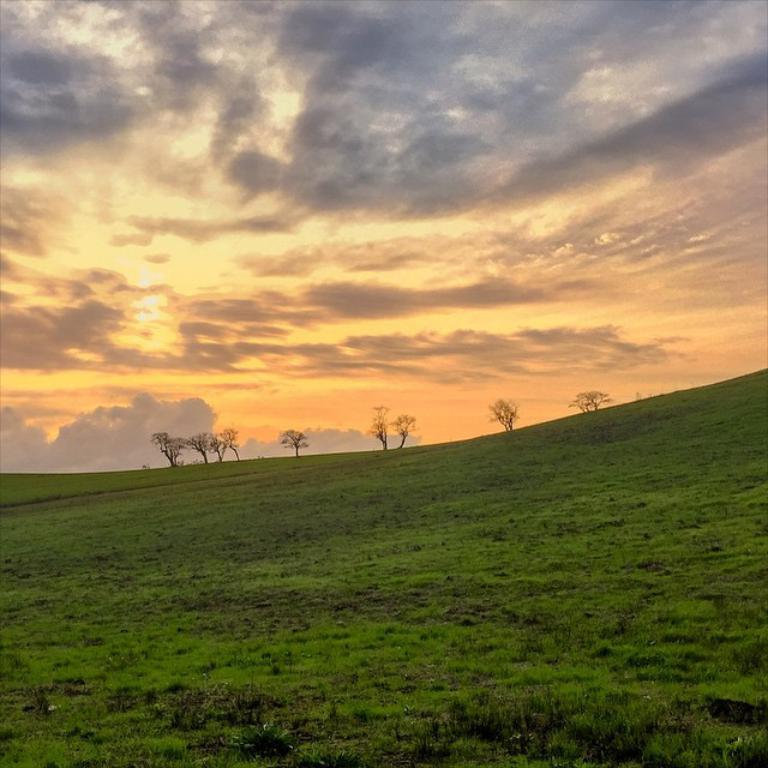What type of vegetation is on the ground in the image? There is grass on the ground in the image. What can be seen in the background of the image? There are trees in the background of the image. What is the condition of the sky in the image? The sky is cloudy in the image. How many pump links are connected in the image? There are no pumps or chains present in the image. What is the rate of increase in the number of clouds in the image? The image does not depict any changes in the number of clouds; it simply shows a cloudy sky. 